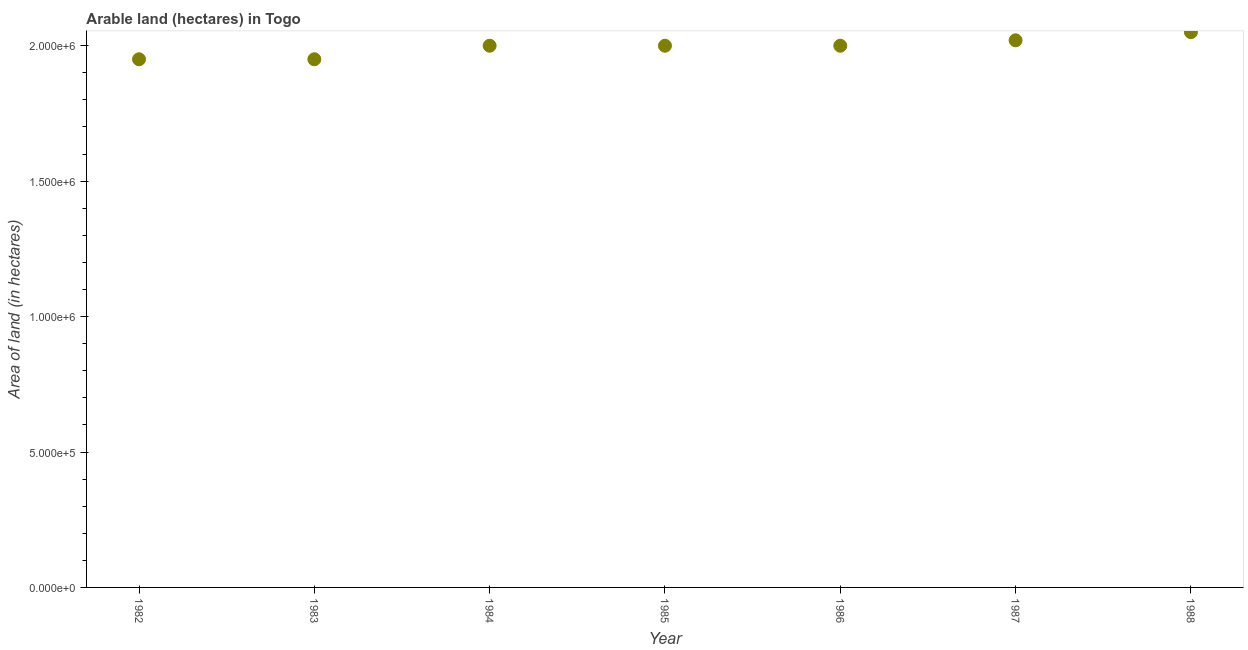What is the area of land in 1982?
Your response must be concise. 1.95e+06. Across all years, what is the maximum area of land?
Your answer should be compact. 2.05e+06. Across all years, what is the minimum area of land?
Give a very brief answer. 1.95e+06. In which year was the area of land minimum?
Keep it short and to the point. 1982. What is the sum of the area of land?
Your answer should be very brief. 1.40e+07. What is the difference between the area of land in 1982 and 1987?
Your response must be concise. -7.00e+04. What is the average area of land per year?
Offer a very short reply. 2.00e+06. Do a majority of the years between 1983 and 1988 (inclusive) have area of land greater than 900000 hectares?
Give a very brief answer. Yes. Is the difference between the area of land in 1982 and 1984 greater than the difference between any two years?
Give a very brief answer. No. Is the sum of the area of land in 1983 and 1988 greater than the maximum area of land across all years?
Your answer should be compact. Yes. What is the difference between the highest and the lowest area of land?
Keep it short and to the point. 1.00e+05. Does the area of land monotonically increase over the years?
Give a very brief answer. No. How many dotlines are there?
Give a very brief answer. 1. What is the difference between two consecutive major ticks on the Y-axis?
Offer a very short reply. 5.00e+05. Are the values on the major ticks of Y-axis written in scientific E-notation?
Provide a short and direct response. Yes. Does the graph contain any zero values?
Your answer should be very brief. No. What is the title of the graph?
Keep it short and to the point. Arable land (hectares) in Togo. What is the label or title of the Y-axis?
Ensure brevity in your answer.  Area of land (in hectares). What is the Area of land (in hectares) in 1982?
Your answer should be compact. 1.95e+06. What is the Area of land (in hectares) in 1983?
Ensure brevity in your answer.  1.95e+06. What is the Area of land (in hectares) in 1986?
Offer a terse response. 2.00e+06. What is the Area of land (in hectares) in 1987?
Make the answer very short. 2.02e+06. What is the Area of land (in hectares) in 1988?
Provide a short and direct response. 2.05e+06. What is the difference between the Area of land (in hectares) in 1982 and 1987?
Keep it short and to the point. -7.00e+04. What is the difference between the Area of land (in hectares) in 1983 and 1985?
Give a very brief answer. -5.00e+04. What is the difference between the Area of land (in hectares) in 1983 and 1987?
Provide a short and direct response. -7.00e+04. What is the difference between the Area of land (in hectares) in 1984 and 1985?
Your response must be concise. 0. What is the difference between the Area of land (in hectares) in 1984 and 1986?
Give a very brief answer. 0. What is the difference between the Area of land (in hectares) in 1984 and 1988?
Offer a very short reply. -5.00e+04. What is the difference between the Area of land (in hectares) in 1985 and 1986?
Make the answer very short. 0. What is the difference between the Area of land (in hectares) in 1986 and 1987?
Make the answer very short. -2.00e+04. What is the difference between the Area of land (in hectares) in 1987 and 1988?
Offer a very short reply. -3.00e+04. What is the ratio of the Area of land (in hectares) in 1982 to that in 1987?
Ensure brevity in your answer.  0.96. What is the ratio of the Area of land (in hectares) in 1982 to that in 1988?
Keep it short and to the point. 0.95. What is the ratio of the Area of land (in hectares) in 1983 to that in 1984?
Give a very brief answer. 0.97. What is the ratio of the Area of land (in hectares) in 1983 to that in 1987?
Provide a succinct answer. 0.96. What is the ratio of the Area of land (in hectares) in 1983 to that in 1988?
Your response must be concise. 0.95. What is the ratio of the Area of land (in hectares) in 1984 to that in 1985?
Provide a short and direct response. 1. What is the ratio of the Area of land (in hectares) in 1984 to that in 1988?
Your response must be concise. 0.98. What is the ratio of the Area of land (in hectares) in 1985 to that in 1986?
Ensure brevity in your answer.  1. 